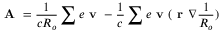Convert formula to latex. <formula><loc_0><loc_0><loc_500><loc_500>A = \frac { 1 } { c R _ { o } } \sum e v - \frac { 1 } { c } \sum e v ( r \nabla \frac { 1 } { R _ { o } } )</formula> 